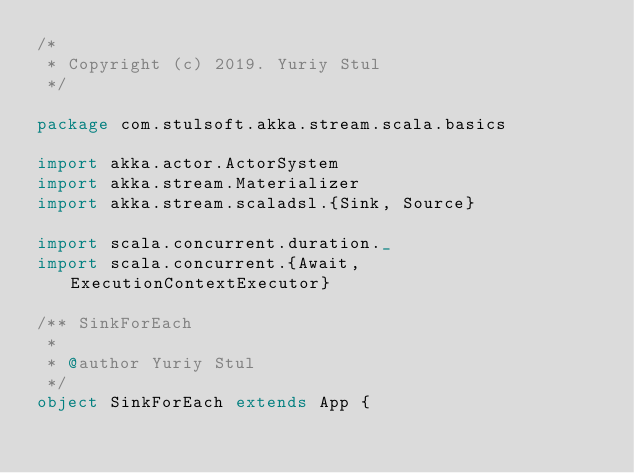Convert code to text. <code><loc_0><loc_0><loc_500><loc_500><_Scala_>/*
 * Copyright (c) 2019. Yuriy Stul
 */

package com.stulsoft.akka.stream.scala.basics

import akka.actor.ActorSystem
import akka.stream.Materializer
import akka.stream.scaladsl.{Sink, Source}

import scala.concurrent.duration._
import scala.concurrent.{Await, ExecutionContextExecutor}

/** SinkForEach
 *
 * @author Yuriy Stul
 */
object SinkForEach extends App {</code> 